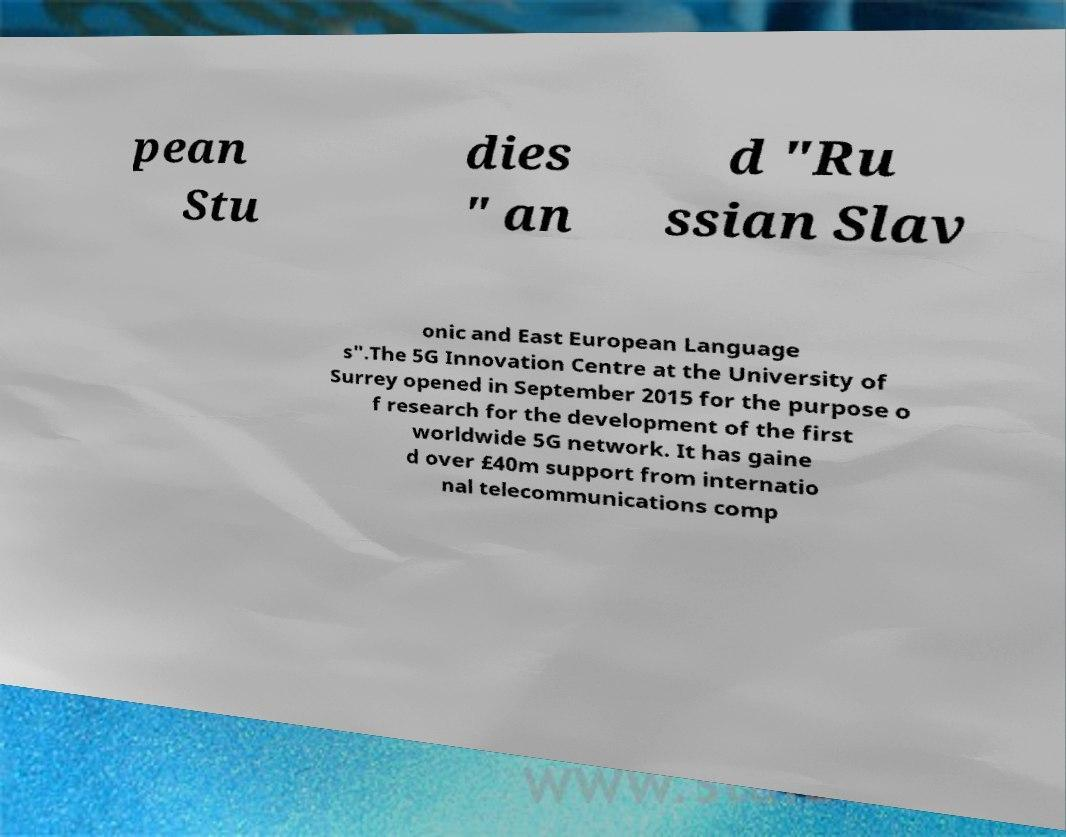What messages or text are displayed in this image? I need them in a readable, typed format. pean Stu dies " an d "Ru ssian Slav onic and East European Language s".The 5G Innovation Centre at the University of Surrey opened in September 2015 for the purpose o f research for the development of the first worldwide 5G network. It has gaine d over £40m support from internatio nal telecommunications comp 